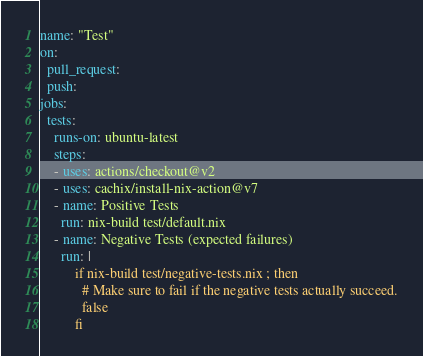Convert code to text. <code><loc_0><loc_0><loc_500><loc_500><_YAML_>name: "Test"
on:
  pull_request:
  push:
jobs:
  tests:
    runs-on: ubuntu-latest
    steps:
    - uses: actions/checkout@v2
    - uses: cachix/install-nix-action@v7
    - name: Positive Tests
      run: nix-build test/default.nix
    - name: Negative Tests (expected failures)
      run: |
          if nix-build test/negative-tests.nix ; then
            # Make sure to fail if the negative tests actually succeed.
            false
          fi

</code> 